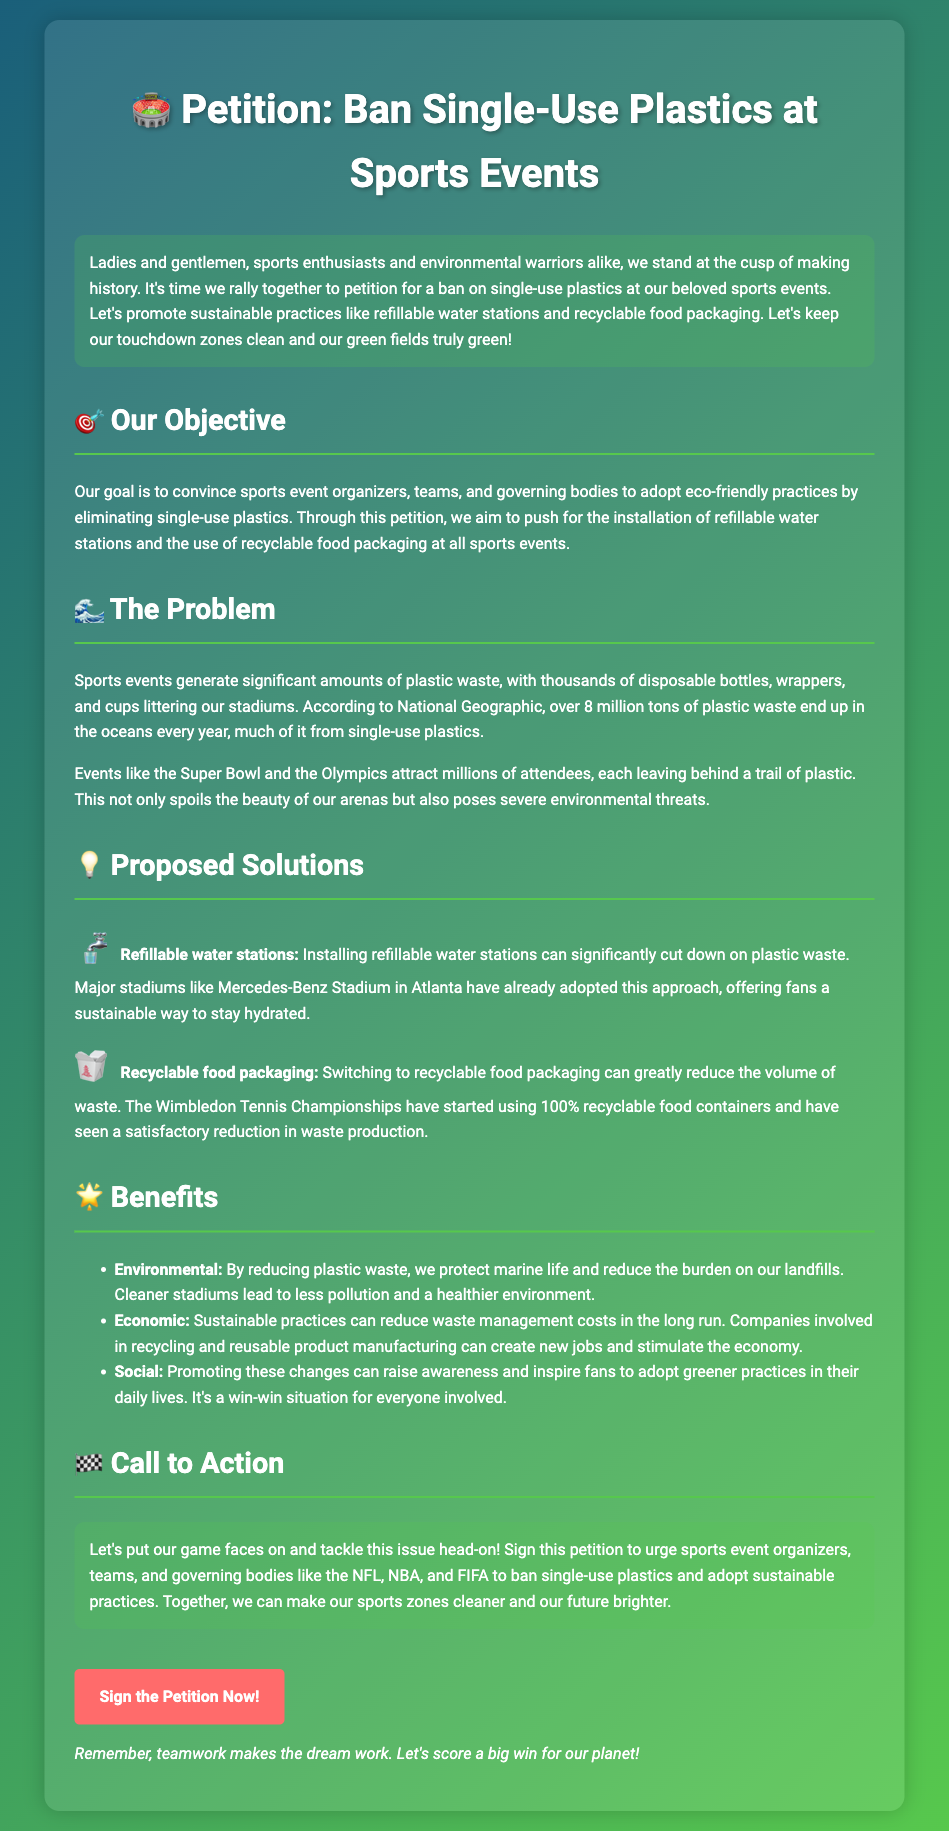What is the main objective of the petition? The main objective is to convince sports event organizers to adopt eco-friendly practices by eliminating single-use plastics.
Answer: To convince sports event organizers to adopt eco-friendly practices What specific environmental issue is addressed in the document? The document highlights the issue of plastic waste generated at sports events and its impact on the environment.
Answer: Plastic waste Which sports events are mentioned as attracting millions of attendees? The document mentions events like the Super Bowl and the Olympics.
Answer: Super Bowl and the Olympics What two sustainable practices are promoted in the petition? The petition promotes installing refillable water stations and using recyclable food packaging.
Answer: Refillable water stations and recyclable food packaging What year did the Wimbledon Tennis Championships start using recyclable food containers? The document does not specify a year for when Wimbledon started using recyclable food containers.
Answer: Not specified What is one economic benefit mentioned in the document? The document states that sustainable practices can reduce waste management costs and create new jobs.
Answer: Reduce waste management costs What phrase emphasizes the importance of teamwork in achieving the petition's goals? The document mentions, "teamwork makes the dream work" to emphasize this point.
Answer: Teamwork makes the dream work What call to action is presented in the petition? The call to action urges individuals to sign the petition to ban single-use plastics at sports events.
Answer: Sign the petition to ban single-use plastics What notable stadium is mentioned for having refillable water stations? The document mentions the Mercedes-Benz Stadium in Atlanta as an example.
Answer: Mercedes-Benz Stadium 